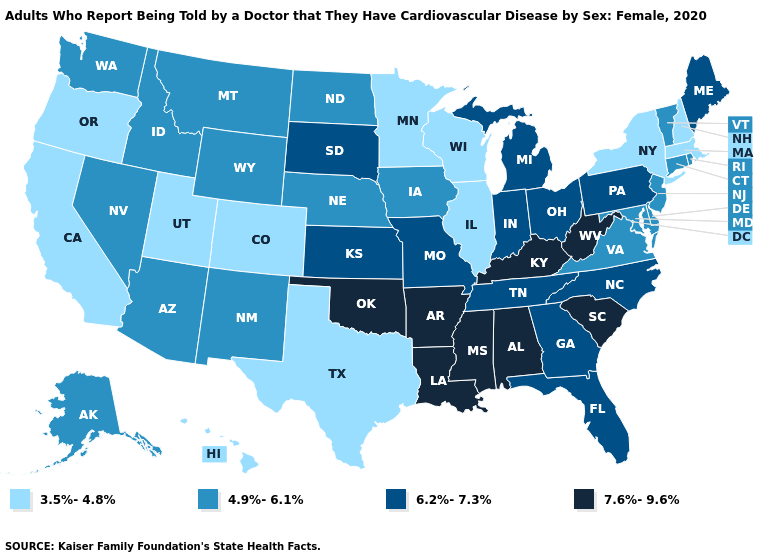Name the states that have a value in the range 7.6%-9.6%?
Concise answer only. Alabama, Arkansas, Kentucky, Louisiana, Mississippi, Oklahoma, South Carolina, West Virginia. Among the states that border Missouri , which have the lowest value?
Write a very short answer. Illinois. What is the value of Louisiana?
Be succinct. 7.6%-9.6%. Is the legend a continuous bar?
Keep it brief. No. What is the value of Oklahoma?
Quick response, please. 7.6%-9.6%. What is the value of Nevada?
Keep it brief. 4.9%-6.1%. Name the states that have a value in the range 6.2%-7.3%?
Quick response, please. Florida, Georgia, Indiana, Kansas, Maine, Michigan, Missouri, North Carolina, Ohio, Pennsylvania, South Dakota, Tennessee. What is the lowest value in the MidWest?
Quick response, please. 3.5%-4.8%. Is the legend a continuous bar?
Concise answer only. No. Does New Mexico have the lowest value in the West?
Answer briefly. No. What is the value of New York?
Short answer required. 3.5%-4.8%. What is the value of New Hampshire?
Write a very short answer. 3.5%-4.8%. Name the states that have a value in the range 6.2%-7.3%?
Write a very short answer. Florida, Georgia, Indiana, Kansas, Maine, Michigan, Missouri, North Carolina, Ohio, Pennsylvania, South Dakota, Tennessee. Name the states that have a value in the range 3.5%-4.8%?
Quick response, please. California, Colorado, Hawaii, Illinois, Massachusetts, Minnesota, New Hampshire, New York, Oregon, Texas, Utah, Wisconsin. Does the map have missing data?
Give a very brief answer. No. 